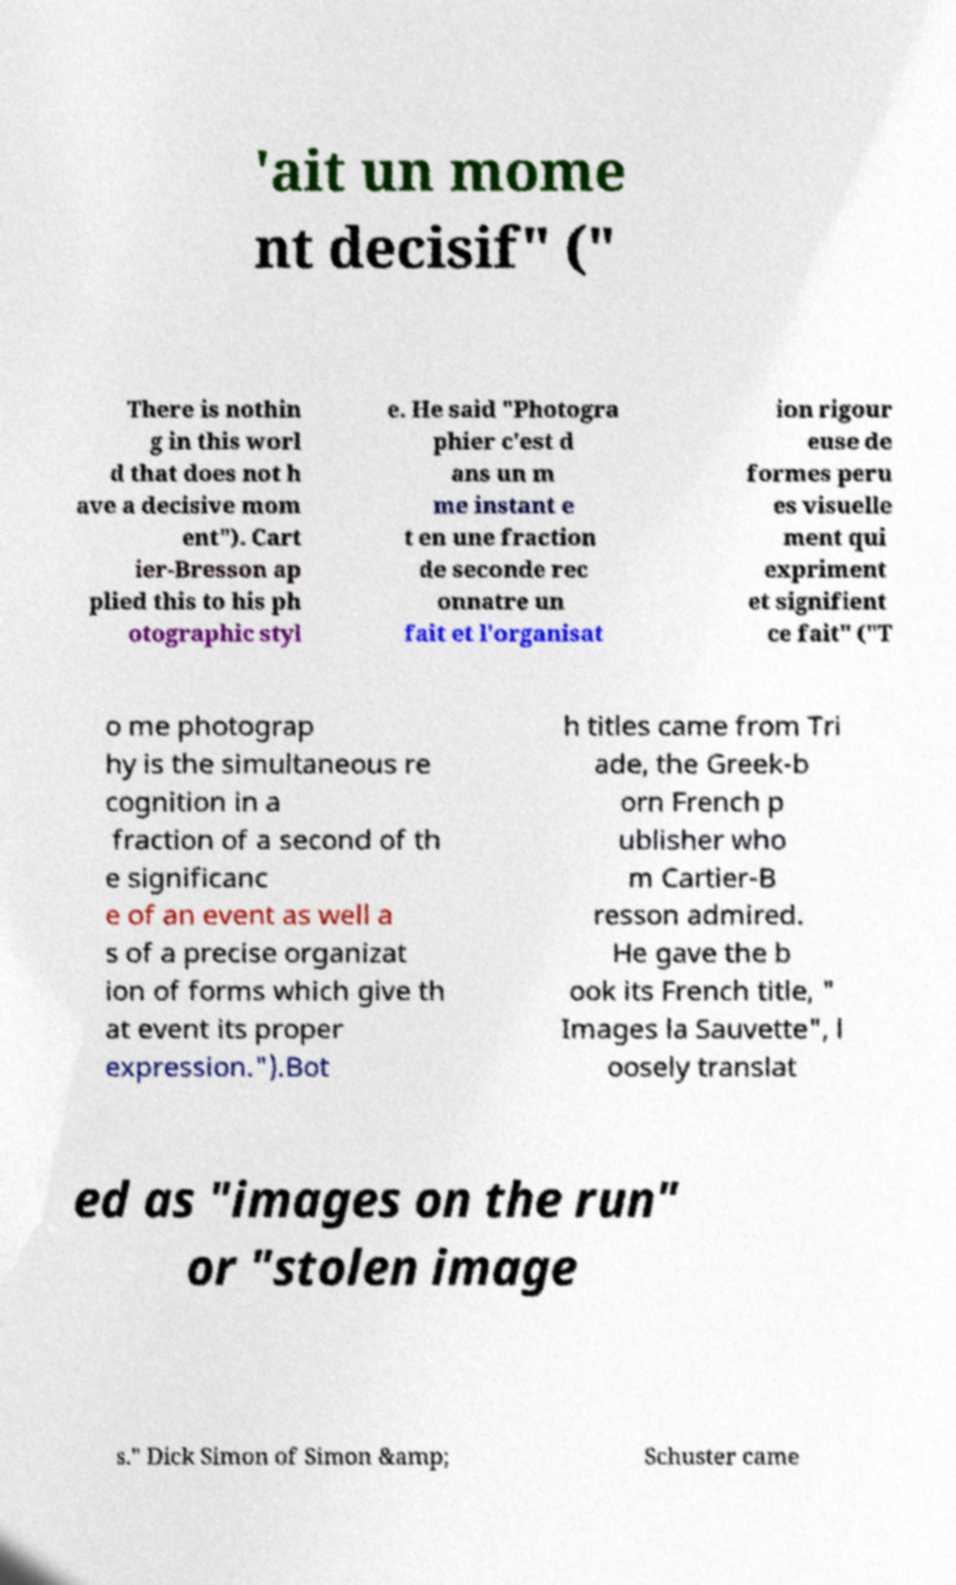Can you accurately transcribe the text from the provided image for me? 'ait un mome nt decisif" (" There is nothin g in this worl d that does not h ave a decisive mom ent"). Cart ier-Bresson ap plied this to his ph otographic styl e. He said "Photogra phier c'est d ans un m me instant e t en une fraction de seconde rec onnatre un fait et l'organisat ion rigour euse de formes peru es visuelle ment qui expriment et signifient ce fait" ("T o me photograp hy is the simultaneous re cognition in a fraction of a second of th e significanc e of an event as well a s of a precise organizat ion of forms which give th at event its proper expression.").Bot h titles came from Tri ade, the Greek-b orn French p ublisher who m Cartier-B resson admired. He gave the b ook its French title, " Images la Sauvette", l oosely translat ed as "images on the run" or "stolen image s." Dick Simon of Simon &amp; Schuster came 